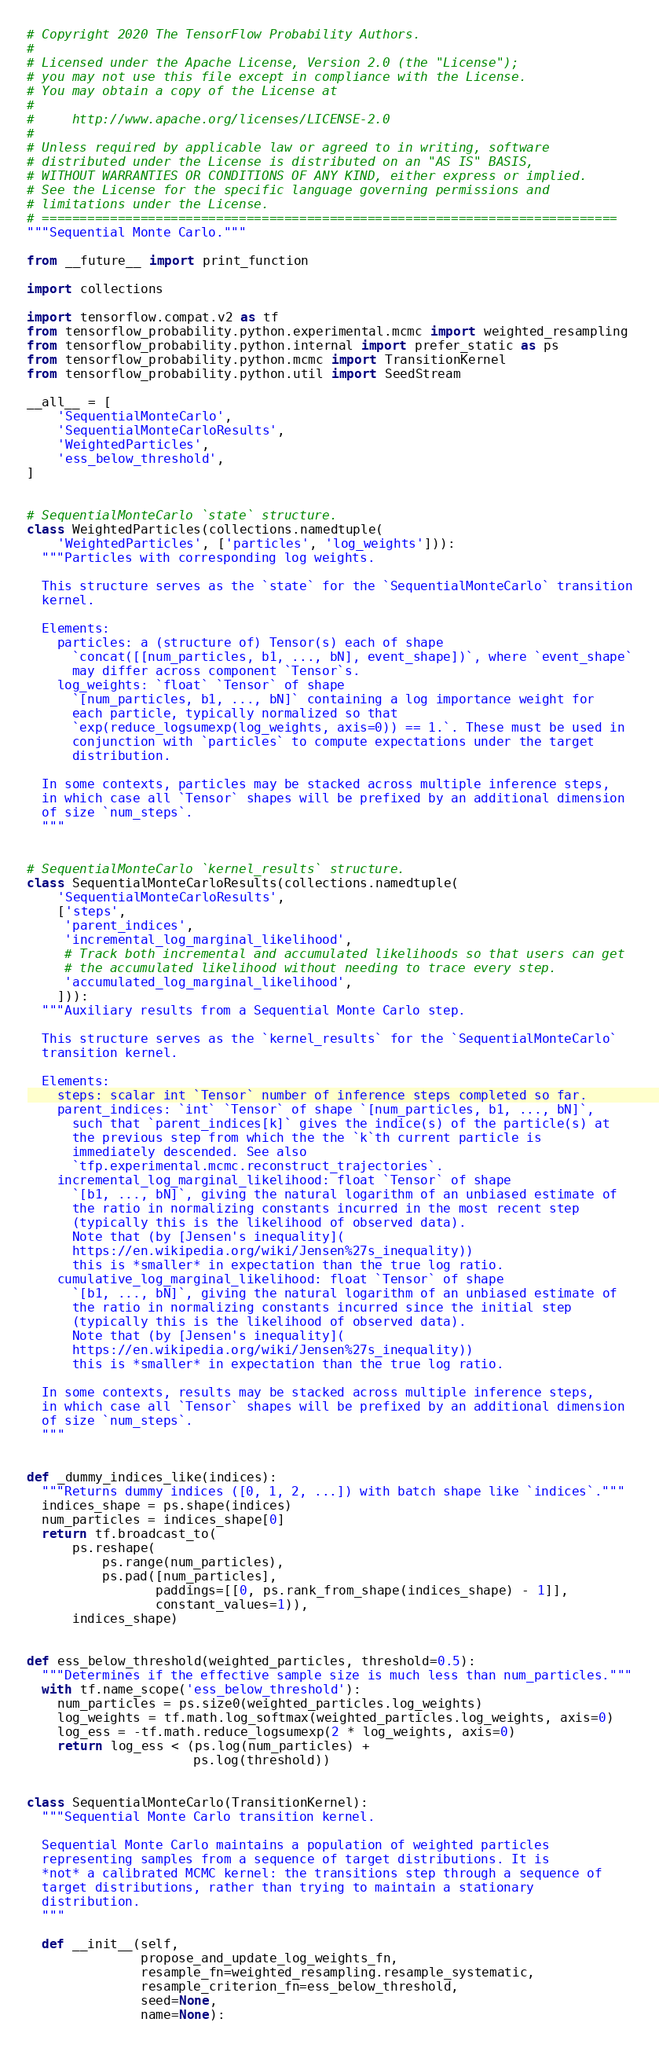Convert code to text. <code><loc_0><loc_0><loc_500><loc_500><_Python_># Copyright 2020 The TensorFlow Probability Authors.
#
# Licensed under the Apache License, Version 2.0 (the "License");
# you may not use this file except in compliance with the License.
# You may obtain a copy of the License at
#
#     http://www.apache.org/licenses/LICENSE-2.0
#
# Unless required by applicable law or agreed to in writing, software
# distributed under the License is distributed on an "AS IS" BASIS,
# WITHOUT WARRANTIES OR CONDITIONS OF ANY KIND, either express or implied.
# See the License for the specific language governing permissions and
# limitations under the License.
# ============================================================================
"""Sequential Monte Carlo."""

from __future__ import print_function

import collections

import tensorflow.compat.v2 as tf
from tensorflow_probability.python.experimental.mcmc import weighted_resampling
from tensorflow_probability.python.internal import prefer_static as ps
from tensorflow_probability.python.mcmc import TransitionKernel
from tensorflow_probability.python.util import SeedStream

__all__ = [
    'SequentialMonteCarlo',
    'SequentialMonteCarloResults',
    'WeightedParticles',
    'ess_below_threshold',
]


# SequentialMonteCarlo `state` structure.
class WeightedParticles(collections.namedtuple(
    'WeightedParticles', ['particles', 'log_weights'])):
  """Particles with corresponding log weights.

  This structure serves as the `state` for the `SequentialMonteCarlo` transition
  kernel.

  Elements:
    particles: a (structure of) Tensor(s) each of shape
      `concat([[num_particles, b1, ..., bN], event_shape])`, where `event_shape`
      may differ across component `Tensor`s.
    log_weights: `float` `Tensor` of shape
      `[num_particles, b1, ..., bN]` containing a log importance weight for
      each particle, typically normalized so that
      `exp(reduce_logsumexp(log_weights, axis=0)) == 1.`. These must be used in
      conjunction with `particles` to compute expectations under the target
      distribution.

  In some contexts, particles may be stacked across multiple inference steps,
  in which case all `Tensor` shapes will be prefixed by an additional dimension
  of size `num_steps`.
  """


# SequentialMonteCarlo `kernel_results` structure.
class SequentialMonteCarloResults(collections.namedtuple(
    'SequentialMonteCarloResults',
    ['steps',
     'parent_indices',
     'incremental_log_marginal_likelihood',
     # Track both incremental and accumulated likelihoods so that users can get
     # the accumulated likelihood without needing to trace every step.
     'accumulated_log_marginal_likelihood',
    ])):
  """Auxiliary results from a Sequential Monte Carlo step.

  This structure serves as the `kernel_results` for the `SequentialMonteCarlo`
  transition kernel.

  Elements:
    steps: scalar int `Tensor` number of inference steps completed so far.
    parent_indices: `int` `Tensor` of shape `[num_particles, b1, ..., bN]`,
      such that `parent_indices[k]` gives the indice(s) of the particle(s) at
      the previous step from which the the `k`th current particle is
      immediately descended. See also
      `tfp.experimental.mcmc.reconstruct_trajectories`.
    incremental_log_marginal_likelihood: float `Tensor` of shape
      `[b1, ..., bN]`, giving the natural logarithm of an unbiased estimate of
      the ratio in normalizing constants incurred in the most recent step
      (typically this is the likelihood of observed data).
      Note that (by [Jensen's inequality](
      https://en.wikipedia.org/wiki/Jensen%27s_inequality))
      this is *smaller* in expectation than the true log ratio.
    cumulative_log_marginal_likelihood: float `Tensor` of shape
      `[b1, ..., bN]`, giving the natural logarithm of an unbiased estimate of
      the ratio in normalizing constants incurred since the initial step
      (typically this is the likelihood of observed data).
      Note that (by [Jensen's inequality](
      https://en.wikipedia.org/wiki/Jensen%27s_inequality))
      this is *smaller* in expectation than the true log ratio.

  In some contexts, results may be stacked across multiple inference steps,
  in which case all `Tensor` shapes will be prefixed by an additional dimension
  of size `num_steps`.
  """


def _dummy_indices_like(indices):
  """Returns dummy indices ([0, 1, 2, ...]) with batch shape like `indices`."""
  indices_shape = ps.shape(indices)
  num_particles = indices_shape[0]
  return tf.broadcast_to(
      ps.reshape(
          ps.range(num_particles),
          ps.pad([num_particles],
                 paddings=[[0, ps.rank_from_shape(indices_shape) - 1]],
                 constant_values=1)),
      indices_shape)


def ess_below_threshold(weighted_particles, threshold=0.5):
  """Determines if the effective sample size is much less than num_particles."""
  with tf.name_scope('ess_below_threshold'):
    num_particles = ps.size0(weighted_particles.log_weights)
    log_weights = tf.math.log_softmax(weighted_particles.log_weights, axis=0)
    log_ess = -tf.math.reduce_logsumexp(2 * log_weights, axis=0)
    return log_ess < (ps.log(num_particles) +
                      ps.log(threshold))


class SequentialMonteCarlo(TransitionKernel):
  """Sequential Monte Carlo transition kernel.

  Sequential Monte Carlo maintains a population of weighted particles
  representing samples from a sequence of target distributions. It is
  *not* a calibrated MCMC kernel: the transitions step through a sequence of
  target distributions, rather than trying to maintain a stationary
  distribution.
  """

  def __init__(self,
               propose_and_update_log_weights_fn,
               resample_fn=weighted_resampling.resample_systematic,
               resample_criterion_fn=ess_below_threshold,
               seed=None,
               name=None):</code> 